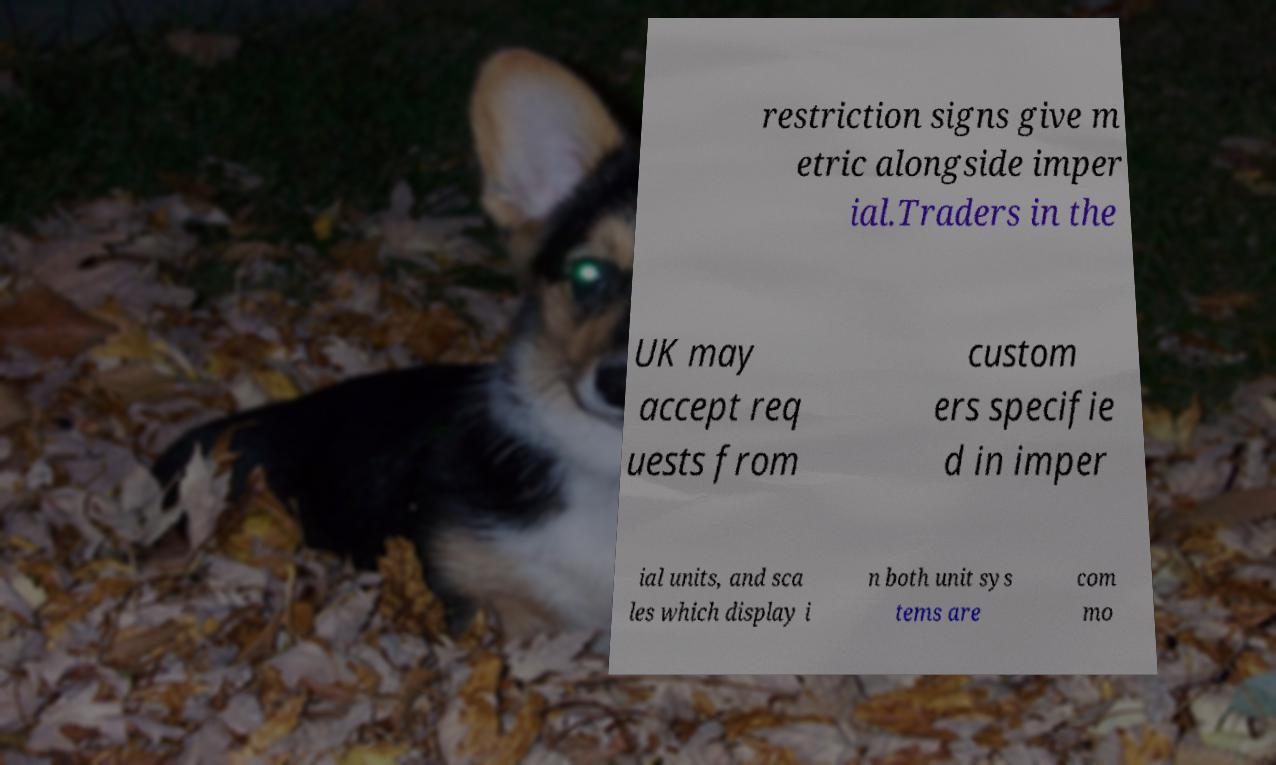Can you read and provide the text displayed in the image?This photo seems to have some interesting text. Can you extract and type it out for me? restriction signs give m etric alongside imper ial.Traders in the UK may accept req uests from custom ers specifie d in imper ial units, and sca les which display i n both unit sys tems are com mo 